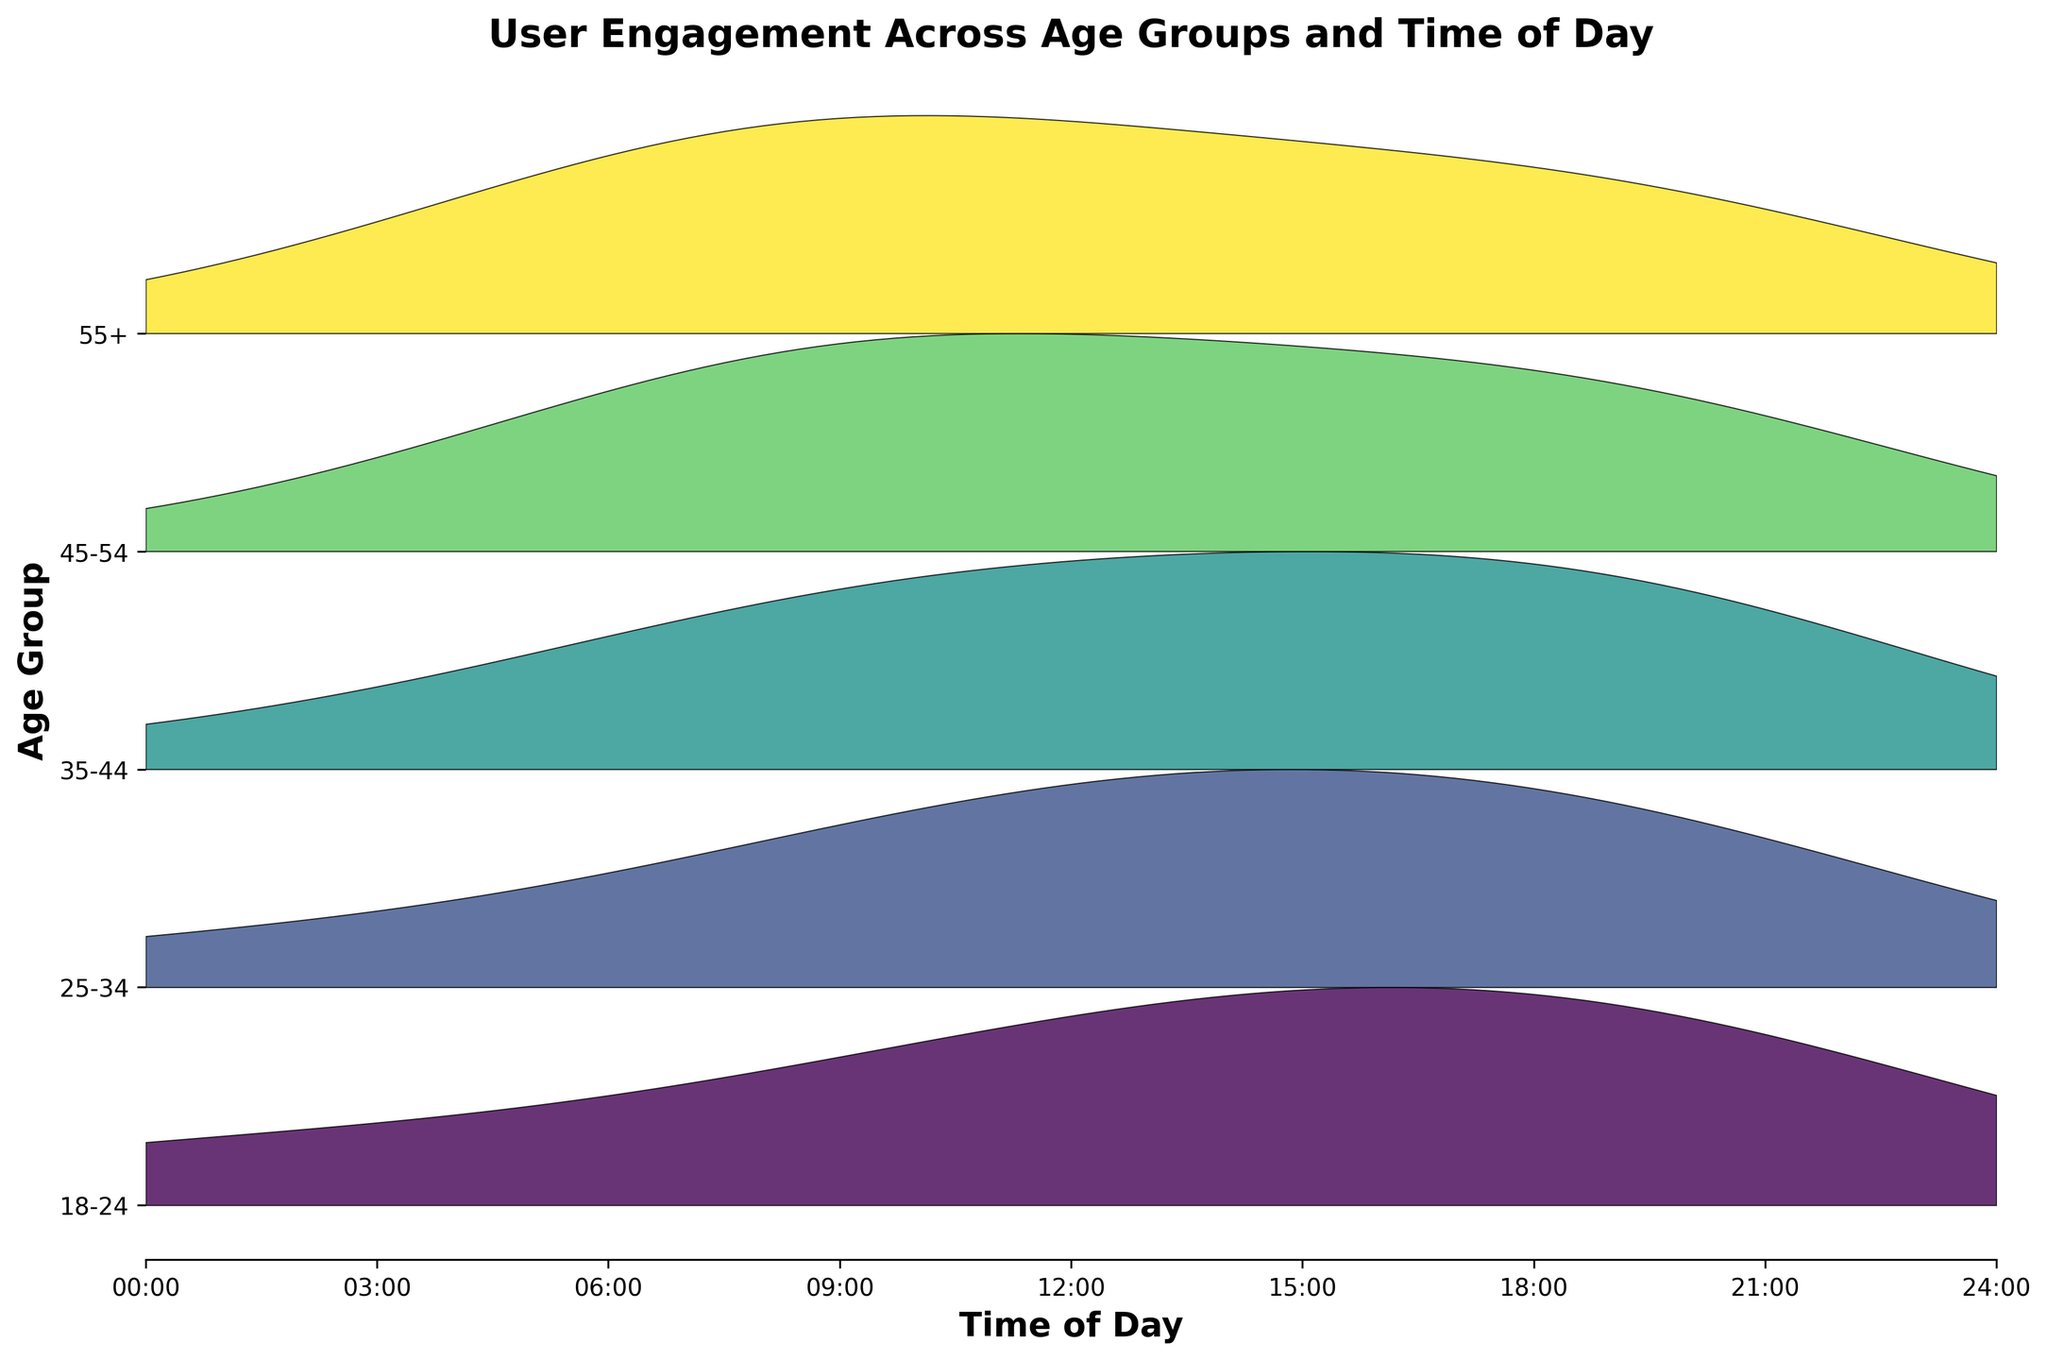What is the title of the figure? The title of the figure is displayed clearly at the top. By reading the top of the chart, we can identify it.
Answer: User Engagement Across Age Groups and Time of Day What are the labels on the x-axis? Looking at the x-axis, we observe how it is labeled. Each tick represents a specific hour of the day, formatted in 'HH:00'.
Answer: 00:00, 03:00, 06:00, 09:00, 12:00, 15:00, 18:00, 21:00 Which age group shows the highest engagement score overall? By observing the extreme ridgelines, the age group with the highest peaks above the reference line throughout the day is identified. The 18-24 group consistently has higher peaks.
Answer: 18-24 How does the engagement score for the 35-44 age group change over the course of the day? We examine the ridgeline for the 35-44 age group across the 24-hour period to see their engagement levels fluctuating. The engagement starts low, peaks around 9:00 and 18:00, and then decreases.
Answer: Peaks at 9:00 and 18:00 Which time of day shows the lowest engagement for the 55+ age group? Tracing the ridgeline for the 55+ group, we identify the time with the lowest peak, which represents minimal engagement. The score is especially low at 0:00 and 15:00.
Answer: 0:00 and 15:00 In which age group does the engagement score peak at 12:00? By looking at all ridgelines at the 12:00 mark, we identify which age group has the highest peak at this specific time. The 25-34 group has the maximum engagement.
Answer: 25-34 Compare the engagement at 18:00 between the 18-24 and 35-44 age groups. Which is higher? Observing the peaks at 18:00 for both the 18-24 and 35-44 groups, we compare their heights to see which is larger. The 18-24 group's peak is higher.
Answer: 18-24 How do the engagement scores at 6:00 compare across all age groups? By examining the 6:00 point in the ridgelines for all age groups, we compare the heights to determine which are higher or lower. The 55+ group has the highest engagement, whereas the 18-24 group has the lowest at this time.
Answer: 55+ highest, 18-24 lowest What is the general trend in user engagement across all age groups post-21:00? By following the ridgelines after 21:00, we identify if the engagement increases, decreases, or remains consistent across age groups. Most ridgelines tend to decline after 21:00.
Answer: Declines At which time is the engagement score most consistent across different age groups? We look for the time point where ridgelines have similar heights across all age groups, indicating consistent engagement. Around 6:00, most age groups have engagement scores close in value.
Answer: 6:00 